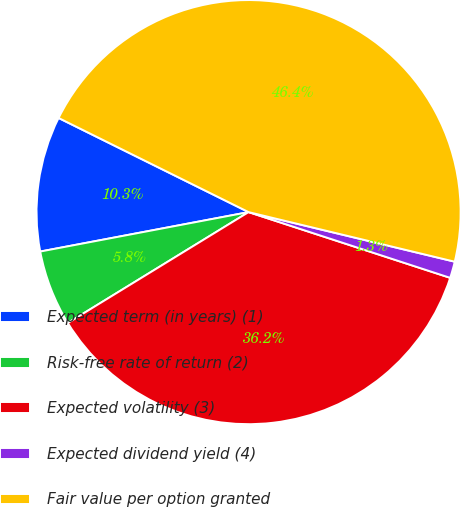Convert chart. <chart><loc_0><loc_0><loc_500><loc_500><pie_chart><fcel>Expected term (in years) (1)<fcel>Risk-free rate of return (2)<fcel>Expected volatility (3)<fcel>Expected dividend yield (4)<fcel>Fair value per option granted<nl><fcel>10.3%<fcel>5.78%<fcel>36.23%<fcel>1.26%<fcel>46.44%<nl></chart> 